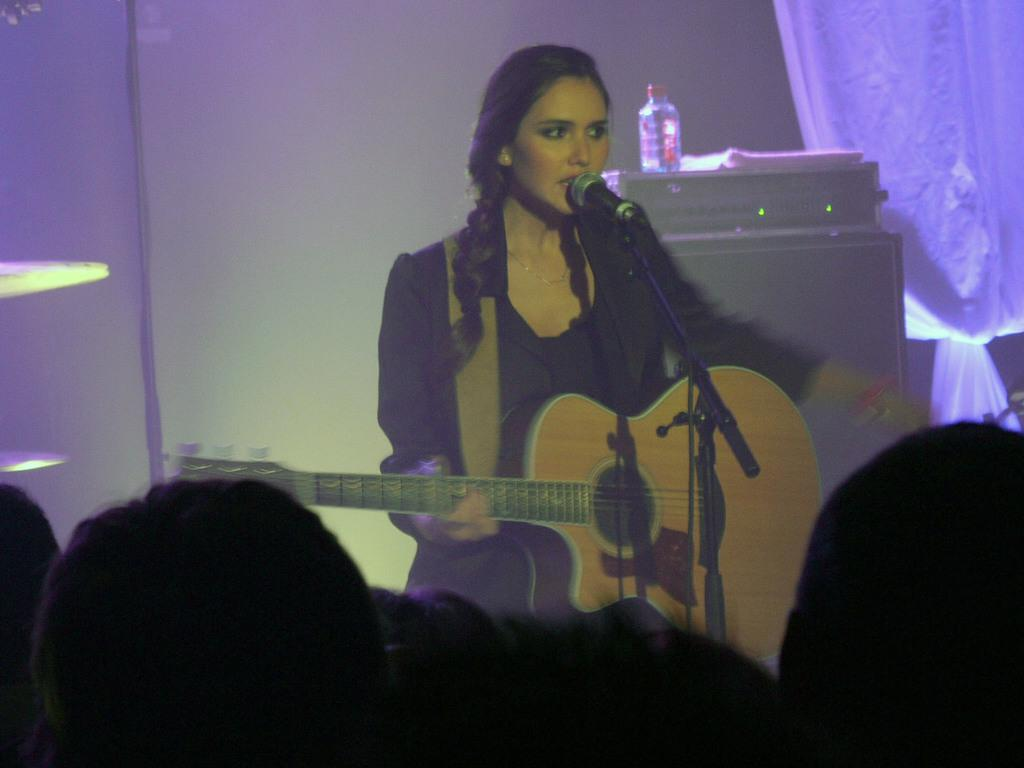Who is the main subject in the image? There is a woman in the image. What is the woman holding in the image? The woman is holding a guitar. Where is the woman positioned in relation to the microphone? The woman is in front of a microphone. What can be seen in the background of the image? There is equipment and a curtain in the background of the image. Can you describe the object on the equipment? There is a bottle on the equipment. What type of punishment is the woman receiving in the image? There is no indication of punishment in the image; the woman is holding a guitar and standing in front of a microphone, which suggests a musical context. 